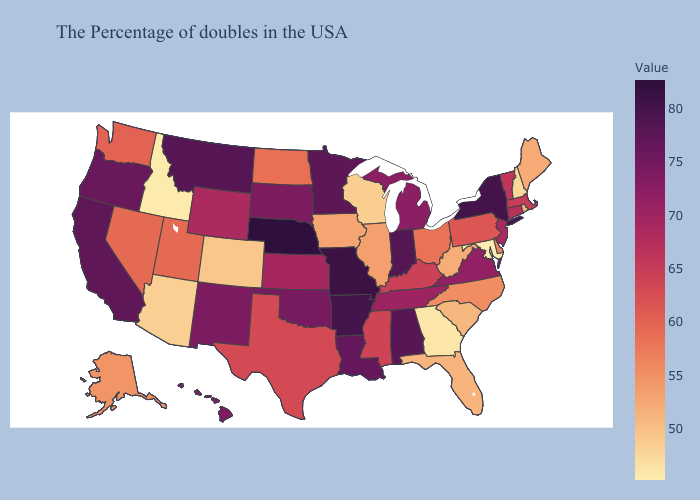Does North Dakota have the highest value in the USA?
Be succinct. No. Does Colorado have a higher value than Kansas?
Concise answer only. No. Does Indiana have the lowest value in the MidWest?
Give a very brief answer. No. Does Hawaii have a lower value than Minnesota?
Keep it brief. Yes. 